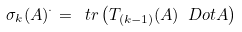Convert formula to latex. <formula><loc_0><loc_0><loc_500><loc_500>\sigma _ { k } ( A ) ^ { \cdot } = \ t r \left ( T _ { ( k - 1 ) } ( A ) \ D o t A \right )</formula> 